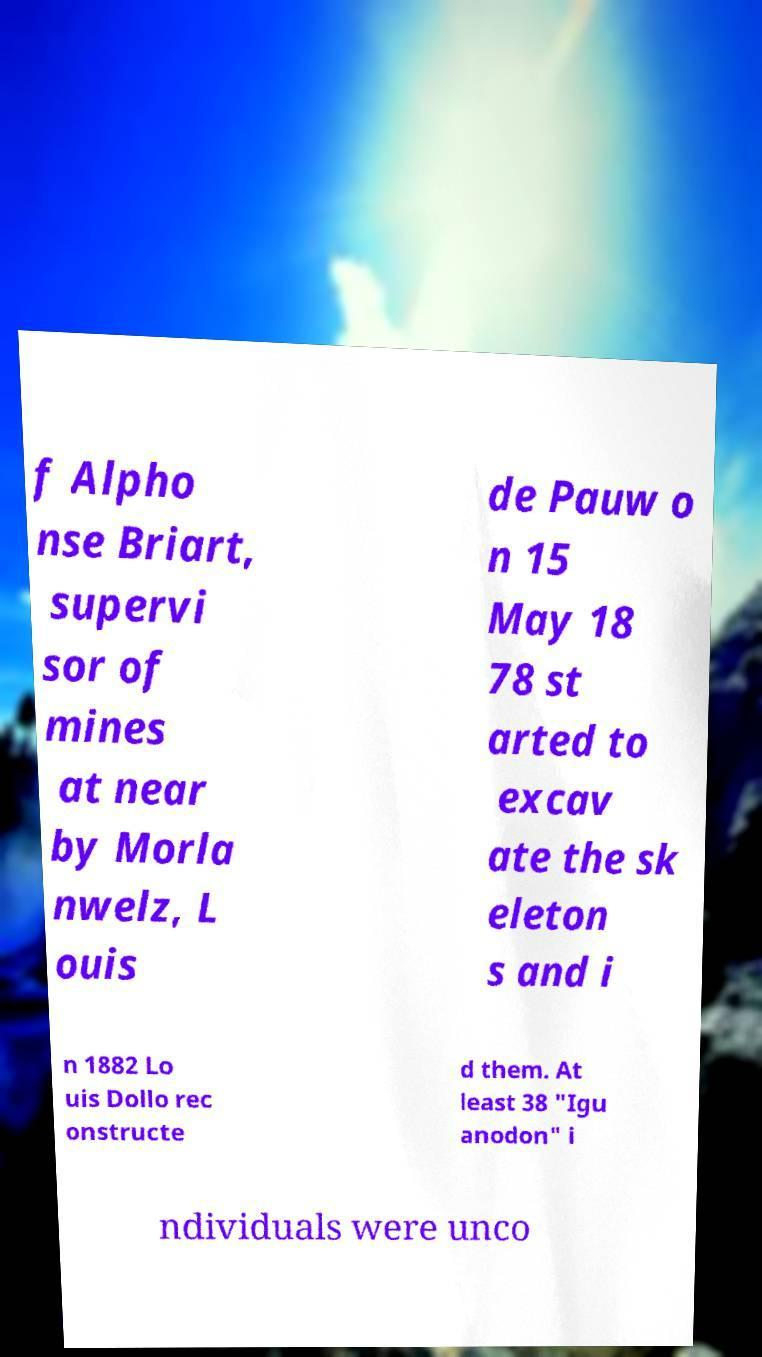Could you assist in decoding the text presented in this image and type it out clearly? f Alpho nse Briart, supervi sor of mines at near by Morla nwelz, L ouis de Pauw o n 15 May 18 78 st arted to excav ate the sk eleton s and i n 1882 Lo uis Dollo rec onstructe d them. At least 38 "Igu anodon" i ndividuals were unco 